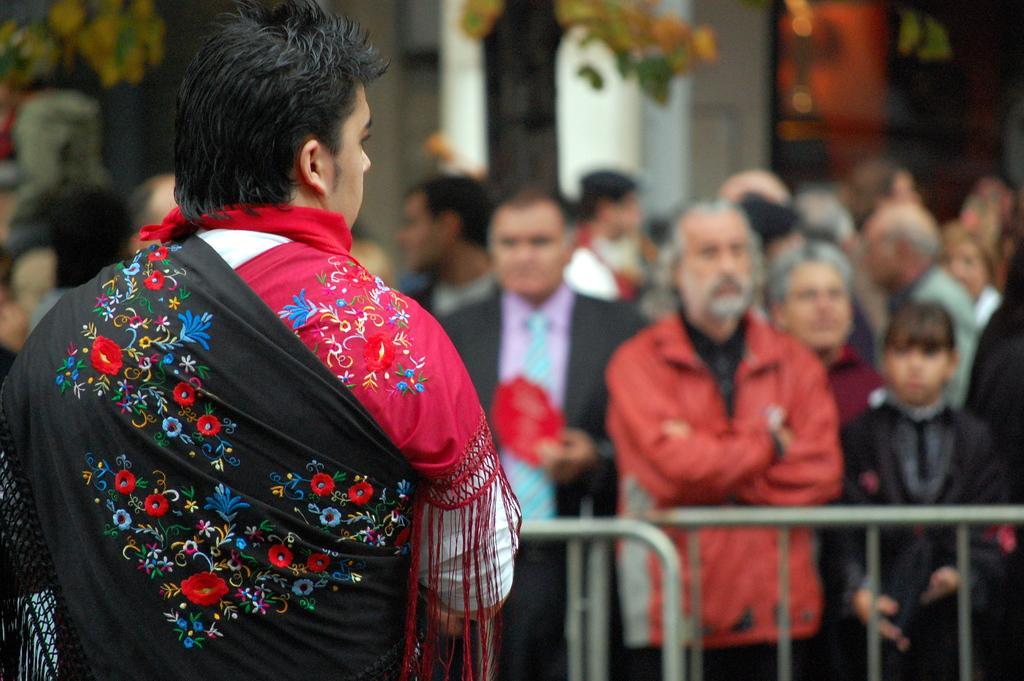Please provide a concise description of this image. In this picture we can see a person and in front of this person we can see a group of people standing, fence, tree and in the background we can see some objects and it is blurry. 